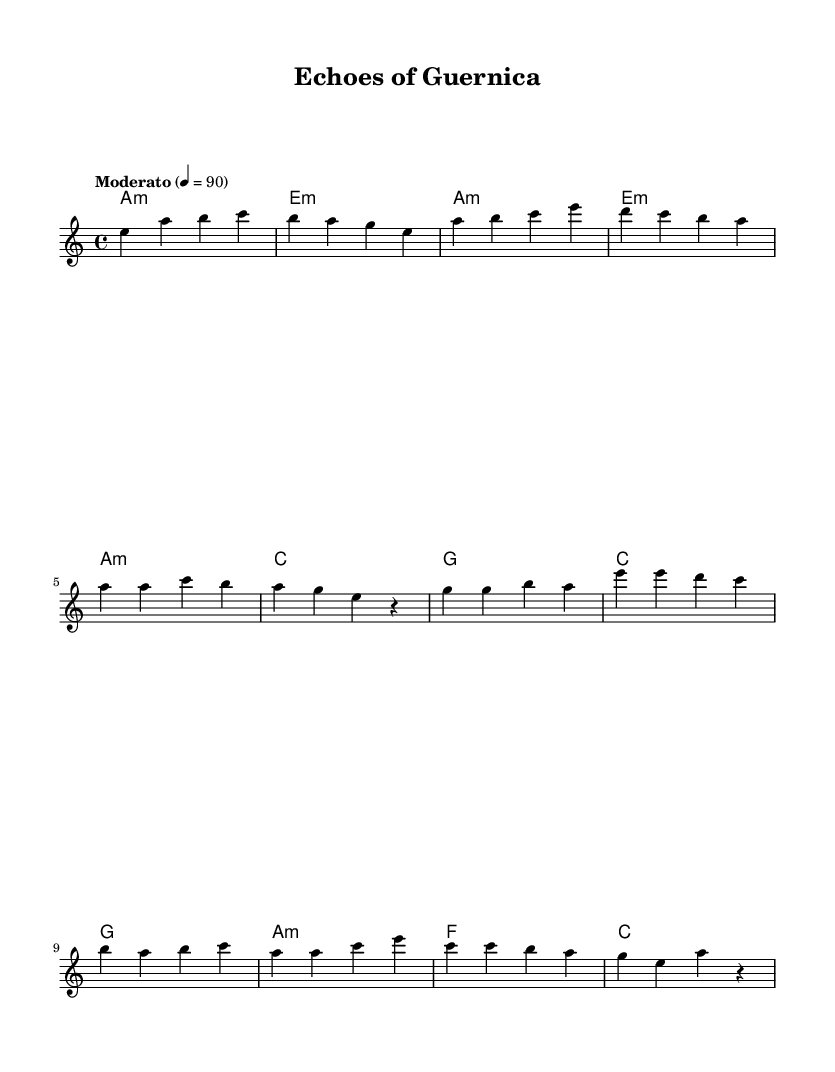What is the key signature of this music? The key signature is A minor, which has no sharps or flats. However, it’s important to note that A minor is the relative minor of C major, and we can see the absence of sharps or flats in the scale.
Answer: A minor What is the time signature of this music? The time signature is 4/4, which indicates four beats per measure. This information is typically found at the beginning of the staff and shows the rhythmic structure of the piece.
Answer: 4/4 What tempo marking is indicated for this piece? The tempo marking is "Moderato," which suggests a moderate speed. This marking is written above the staff and indicates how quickly the music should be played, typically around 90 beats per minute.
Answer: Moderato What is the first chord of the song? The first chord indicated in the score is A minor, which is a minor chord built on the first degree of the A minor scale. It can be seen at the beginning of the harmonies section.
Answer: A minor How many measures are present in the melody? The melody section includes eight measures, as counted from the beginning to the end of the provided snippet. Each group of numbers represents the measures in the melody.
Answer: Eight What type of musical structure does the piece use in the chorus? The piece uses a simple repeated structure in the chorus, which reflects common patterns in country music. This can be claimed by analyzing the melodic phrase lengths and the chord progressions in the indicated section.
Answer: Repeated structure Which historical event inspires the theme of this music? The theme of this music is inspired by the Spanish Civil War, specifically relating to stories from that period. This can be inferred from the title of the piece "Echoes of Guernica," which references the famous bombing during the war.
Answer: Spanish Civil War 